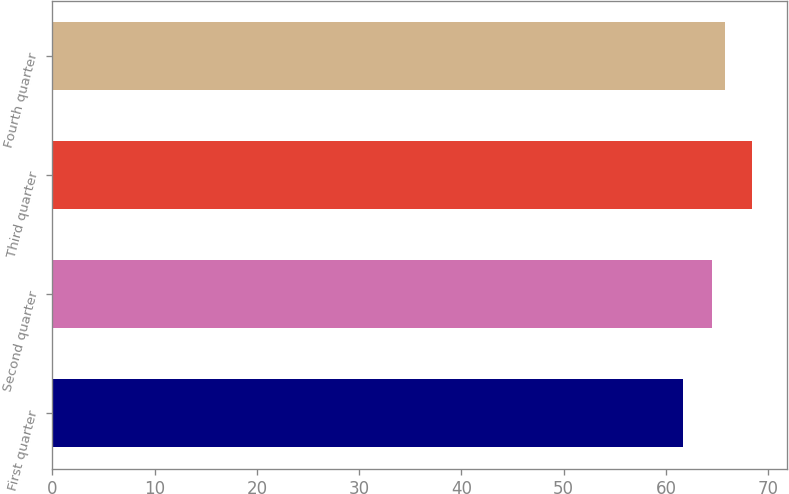Convert chart. <chart><loc_0><loc_0><loc_500><loc_500><bar_chart><fcel>First quarter<fcel>Second quarter<fcel>Third quarter<fcel>Fourth quarter<nl><fcel>61.7<fcel>64.47<fcel>68.41<fcel>65.73<nl></chart> 